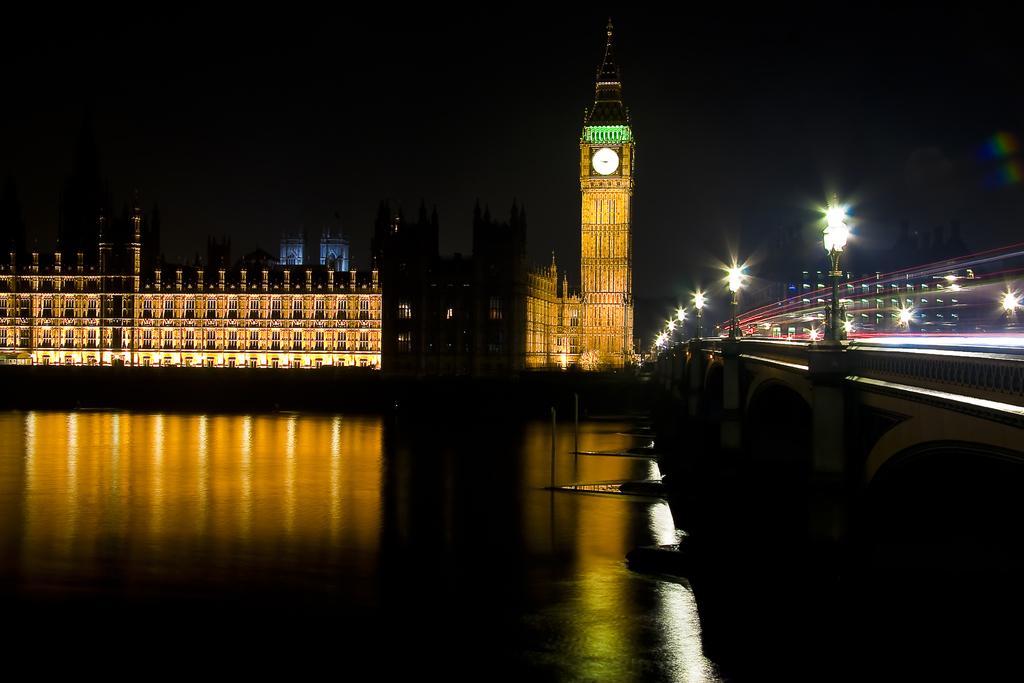How would you summarize this image in a sentence or two? In the foreground I can see water, bridge, light poles, vehicles on the road, fence and trees. In the background I can see buildings, towers, clock tower and the sky. This image is taken may be during night. 